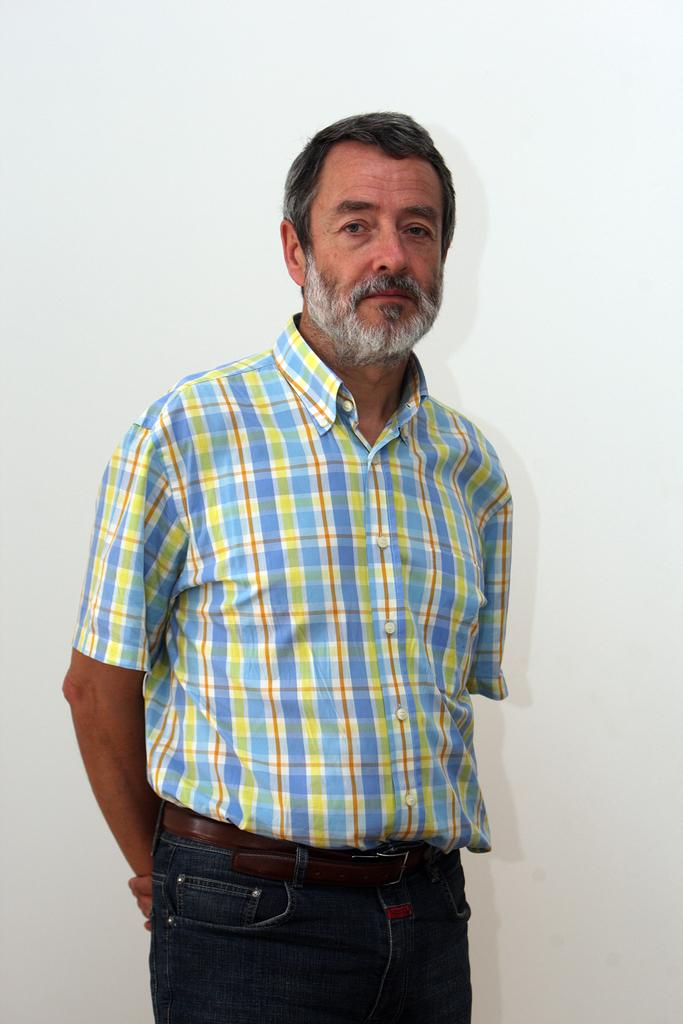What is the main subject of the picture? The main subject of the picture is a man standing. What can be seen in the background of the image? The background of the image is white. What type of cart is visible in the image? There is no cart present in the image; it only features a man standing against a white background. What letters or verses can be seen in the image? There are no letters or verses visible in the image; it only features a man standing against a white background. 